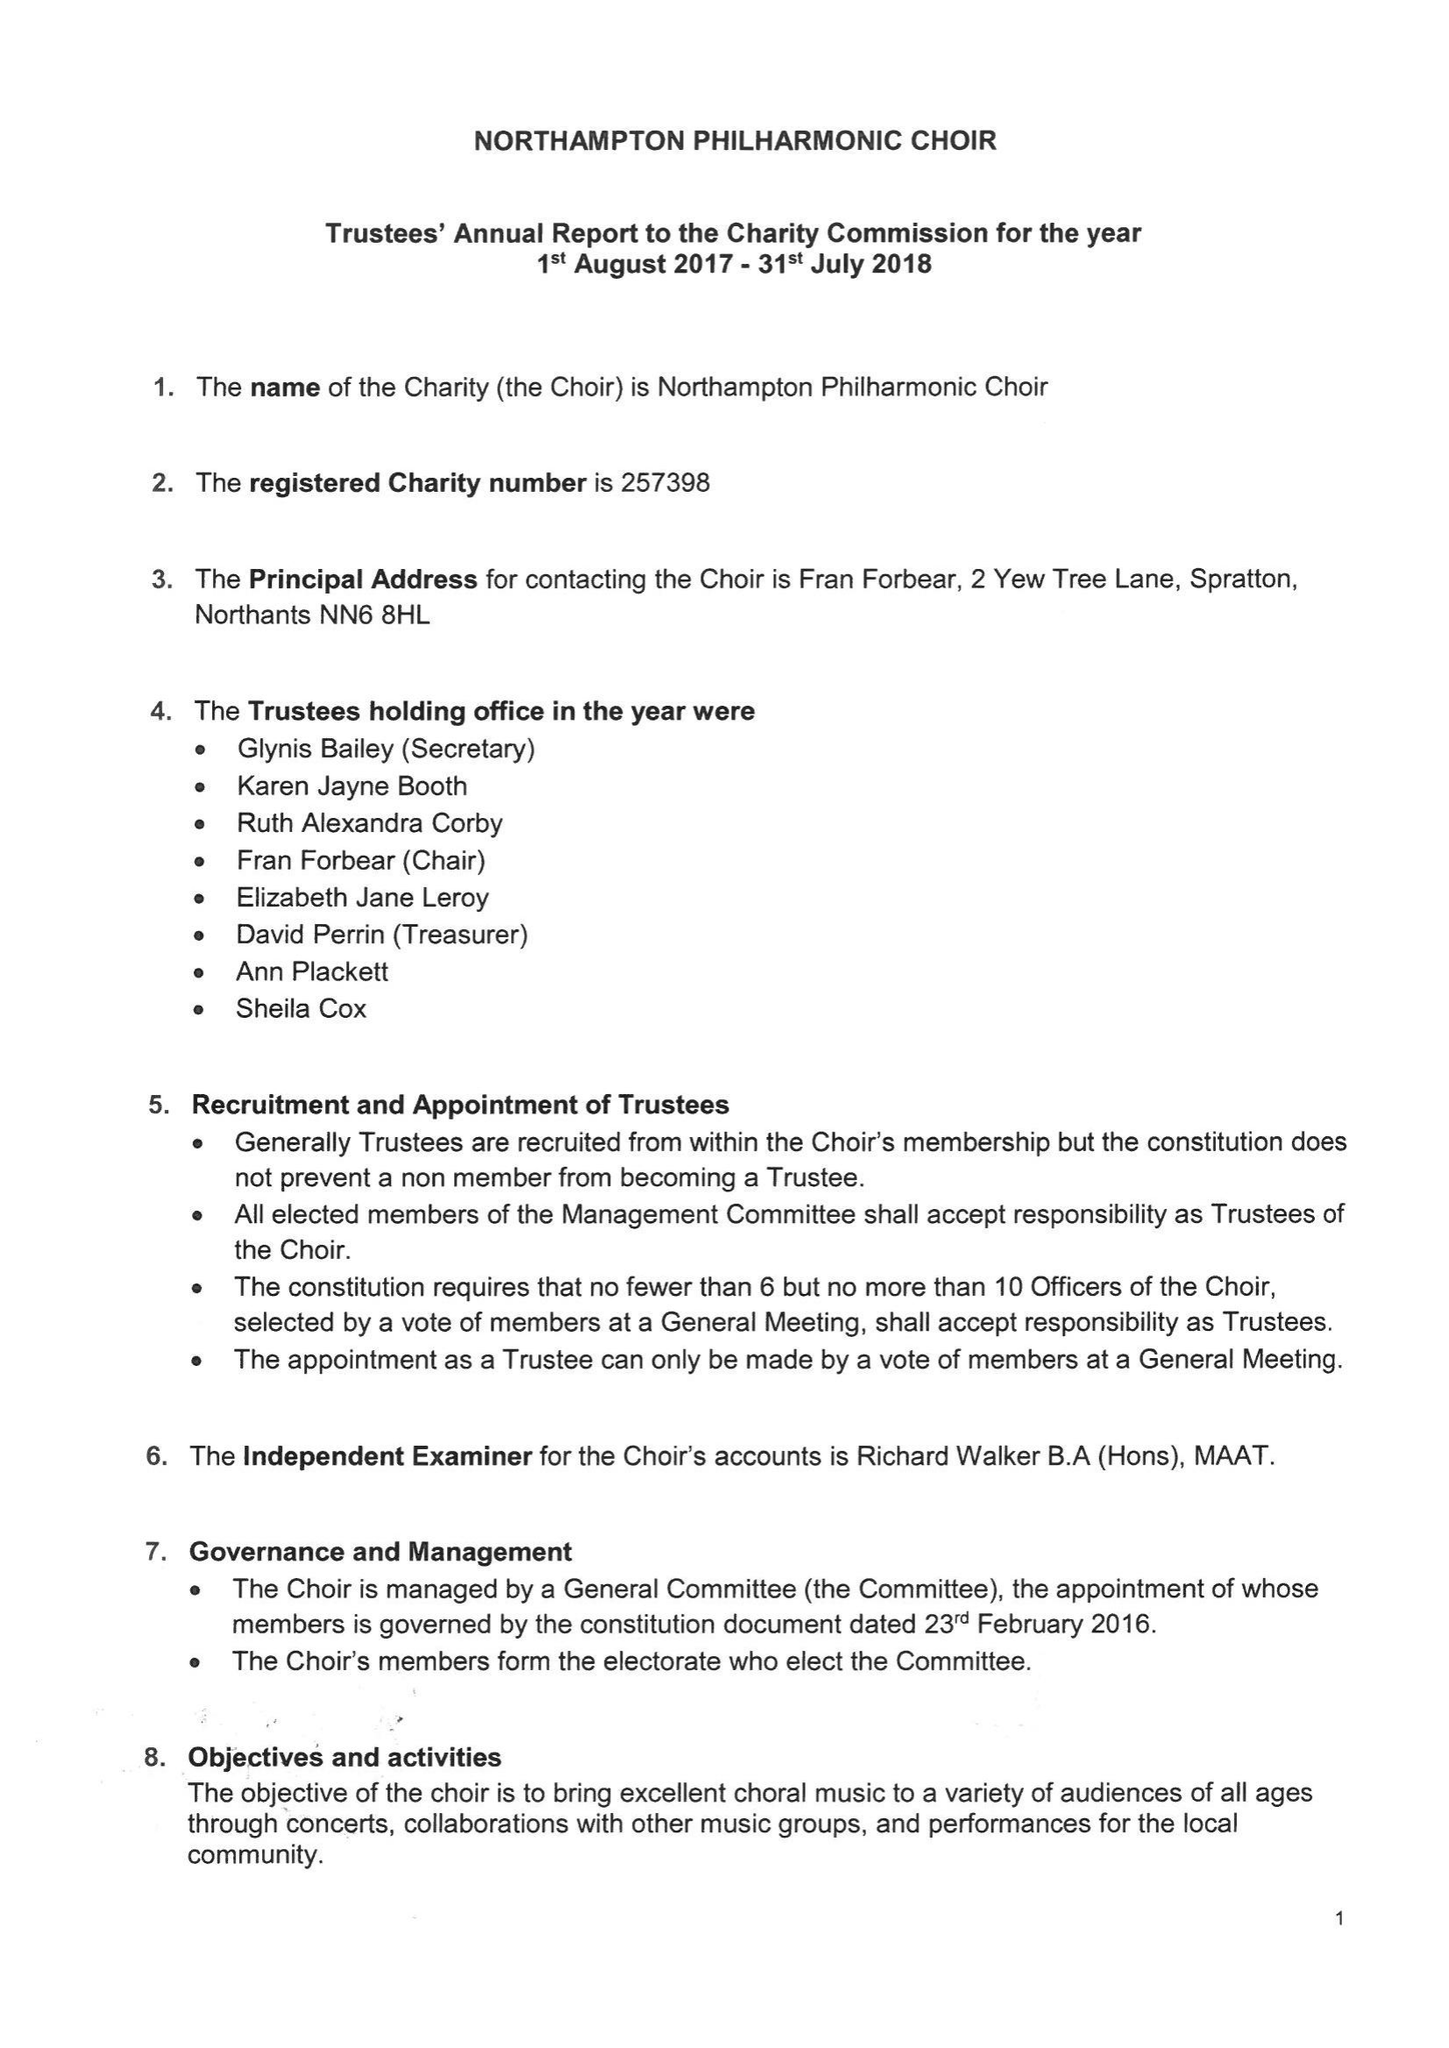What is the value for the spending_annually_in_british_pounds?
Answer the question using a single word or phrase. 24260.00 